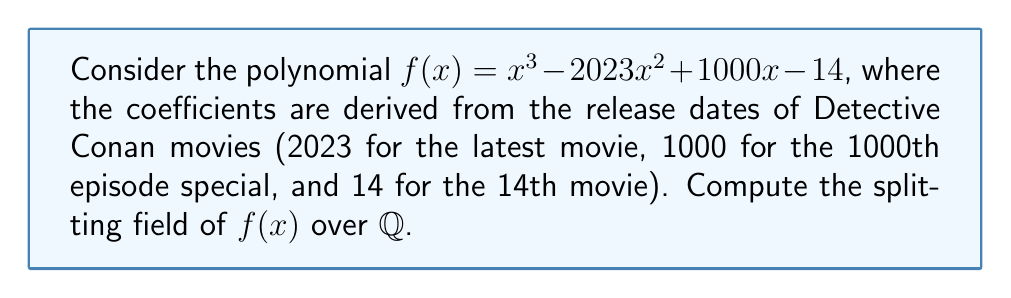Can you solve this math problem? To find the splitting field of $f(x)$ over $\mathbb{Q}$, we need to follow these steps:

1) First, we need to factor $f(x)$ completely over $\mathbb{C}$.

2) Let's denote the roots of $f(x)$ as $\alpha$, $\beta$, and $\gamma$. The splitting field will be $\mathbb{Q}(\alpha, \beta, \gamma)$.

3) We can use the rational root theorem to check for rational roots. The possible rational roots are the factors of 14: $\pm 1, \pm 2, \pm 7, \pm 14$.

4) Testing these, we find that 7 is a root of $f(x)$. So we can factor out $(x-7)$:

   $f(x) = (x-7)(x^2 - 2016x + 2)$

5) The quadratic factor $x^2 - 2016x + 2$ doesn't have rational roots, so it's irreducible over $\mathbb{Q}$.

6) Let $\delta = \sqrt{2016^2 - 4(2)} = \sqrt{4064254}$. Then the roots of the quadratic factor are:

   $\frac{2016 \pm \delta}{2}$

7) Therefore, the splitting field of $f(x)$ over $\mathbb{Q}$ is $\mathbb{Q}(\delta)$, which is equivalent to $\mathbb{Q}(\sqrt{4064254})$.
Answer: $\mathbb{Q}(\sqrt{4064254})$ 